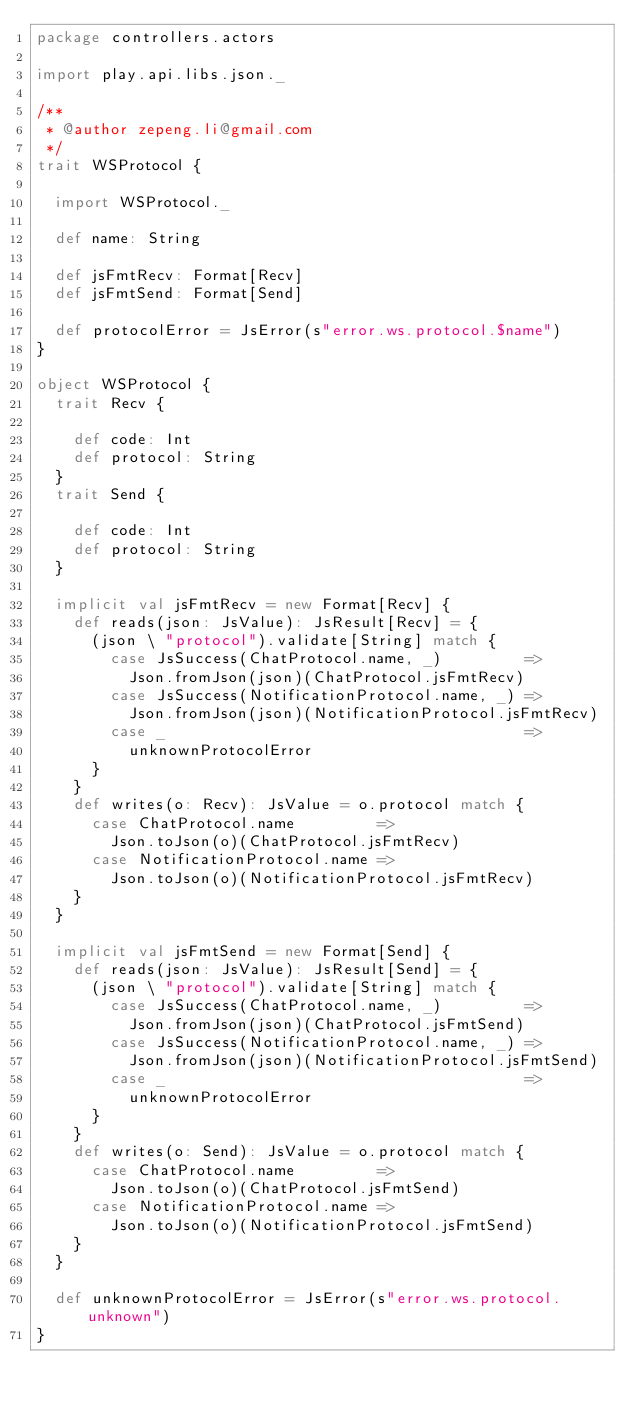<code> <loc_0><loc_0><loc_500><loc_500><_Scala_>package controllers.actors

import play.api.libs.json._

/**
 * @author zepeng.li@gmail.com
 */
trait WSProtocol {

  import WSProtocol._

  def name: String

  def jsFmtRecv: Format[Recv]
  def jsFmtSend: Format[Send]

  def protocolError = JsError(s"error.ws.protocol.$name")
}

object WSProtocol {
  trait Recv {

    def code: Int
    def protocol: String
  }
  trait Send {

    def code: Int
    def protocol: String
  }

  implicit val jsFmtRecv = new Format[Recv] {
    def reads(json: JsValue): JsResult[Recv] = {
      (json \ "protocol").validate[String] match {
        case JsSuccess(ChatProtocol.name, _)         =>
          Json.fromJson(json)(ChatProtocol.jsFmtRecv)
        case JsSuccess(NotificationProtocol.name, _) =>
          Json.fromJson(json)(NotificationProtocol.jsFmtRecv)
        case _                                       =>
          unknownProtocolError
      }
    }
    def writes(o: Recv): JsValue = o.protocol match {
      case ChatProtocol.name         =>
        Json.toJson(o)(ChatProtocol.jsFmtRecv)
      case NotificationProtocol.name =>
        Json.toJson(o)(NotificationProtocol.jsFmtRecv)
    }
  }

  implicit val jsFmtSend = new Format[Send] {
    def reads(json: JsValue): JsResult[Send] = {
      (json \ "protocol").validate[String] match {
        case JsSuccess(ChatProtocol.name, _)         =>
          Json.fromJson(json)(ChatProtocol.jsFmtSend)
        case JsSuccess(NotificationProtocol.name, _) =>
          Json.fromJson(json)(NotificationProtocol.jsFmtSend)
        case _                                       =>
          unknownProtocolError
      }
    }
    def writes(o: Send): JsValue = o.protocol match {
      case ChatProtocol.name         =>
        Json.toJson(o)(ChatProtocol.jsFmtSend)
      case NotificationProtocol.name =>
        Json.toJson(o)(NotificationProtocol.jsFmtSend)
    }
  }

  def unknownProtocolError = JsError(s"error.ws.protocol.unknown")
}</code> 